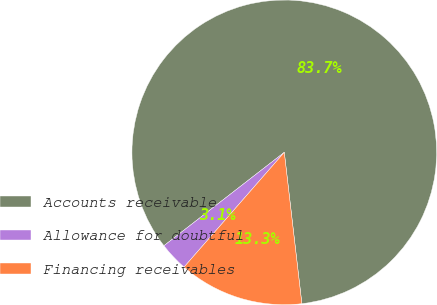<chart> <loc_0><loc_0><loc_500><loc_500><pie_chart><fcel>Accounts receivable<fcel>Allowance for doubtful<fcel>Financing receivables<nl><fcel>83.66%<fcel>3.07%<fcel>13.27%<nl></chart> 